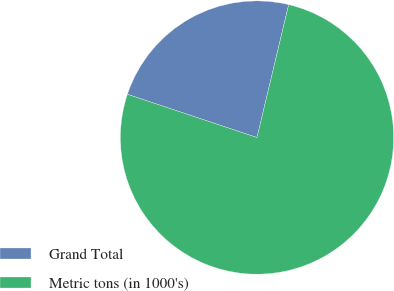<chart> <loc_0><loc_0><loc_500><loc_500><pie_chart><fcel>Grand Total<fcel>Metric tons (in 1000's)<nl><fcel>23.6%<fcel>76.4%<nl></chart> 